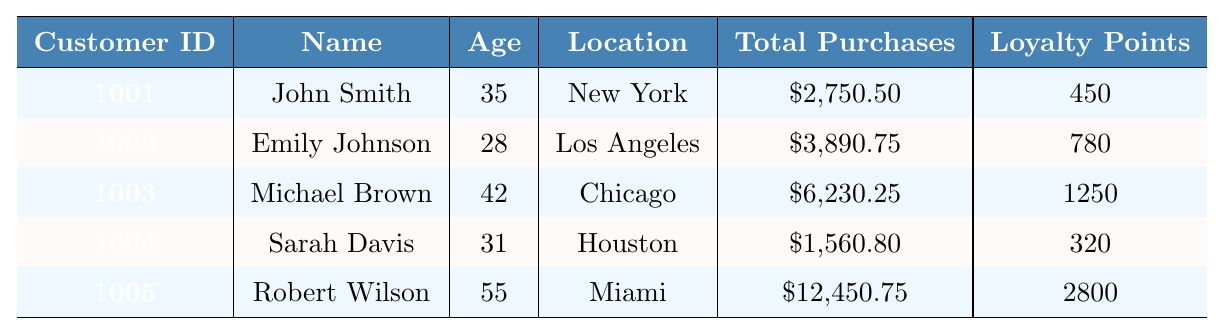What is the total number of loyalty points for all customers? To find the total, sum the loyalty points for each customer: 450 + 780 + 1250 + 320 + 2800 = 5100
Answer: 5100 Who is the customer with the highest total purchases? Among the customers, Robert Wilson has the highest total purchases at \$12,450.75
Answer: Robert Wilson Is there any customer who uses a debit card as their preferred payment method? Referring to the table, only Michael Brown has selected a debit card as their preferred payment method
Answer: Yes What is the average age of all customers? Sum the ages of all customers: 35 + 28 + 42 + 31 + 55 = 191. There are 5 customers, so the average age is 191 / 5 = 38.2
Answer: 38.2 Which customer has the lowest average order value? By observing the average order values, Sarah Davis has the lowest at \$97.55
Answer: Sarah Davis How many customers have a subscription status of "Premium"? Checking the subscription statuses, John Smith, Michael Brown, and Robert Wilson are marked as "Premium", making it a total of three
Answer: 3 What’s the difference in total purchases between the highest and lowest customer? The highest total purchases are \$12,450.75 (Robert Wilson) and the lowest is \$1,560.80 (Sarah Davis). The difference is \$12,450.75 - \$1,560.80 = \$10,889.95
Answer: \$10,889.95 Is the preferred category for Emily Johnson "Apparel"? Looking at the table, Emily Johnson does have "Apparel" listed as her preferred category
Answer: Yes Which location has the customer with the highest average visits per month? Michael Brown is located in Chicago and visits on average 2.8 times per month, while Sarah Davis from Houston averages 4.1 visits. Thus, the location with the most visits is Houston
Answer: Houston What is the total amount of purchases made by customers who have a subscription status of "Standard"? Sarah Davis and Emily Johnson have standard subscriptions. Their total purchases are \$1,560.80 + \$3,890.75 = \$5,451.55
Answer: \$5,451.55 